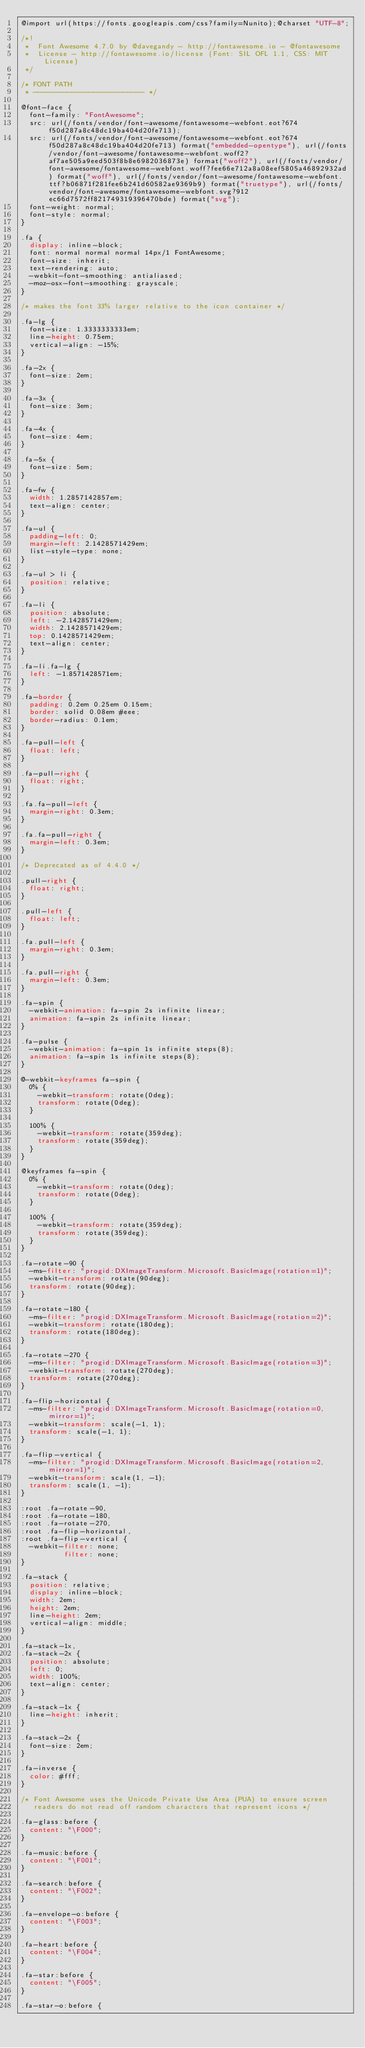Convert code to text. <code><loc_0><loc_0><loc_500><loc_500><_CSS_>@import url(https://fonts.googleapis.com/css?family=Nunito);@charset "UTF-8";

/*!
 *  Font Awesome 4.7.0 by @davegandy - http://fontawesome.io - @fontawesome
 *  License - http://fontawesome.io/license (Font: SIL OFL 1.1, CSS: MIT License)
 */

/* FONT PATH
 * -------------------------- */

@font-face {
  font-family: "FontAwesome";
  src: url(/fonts/vendor/font-awesome/fontawesome-webfont.eot?674f50d287a8c48dc19ba404d20fe713);
  src: url(/fonts/vendor/font-awesome/fontawesome-webfont.eot?674f50d287a8c48dc19ba404d20fe713) format("embedded-opentype"), url(/fonts/vendor/font-awesome/fontawesome-webfont.woff2?af7ae505a9eed503f8b8e6982036873e) format("woff2"), url(/fonts/vendor/font-awesome/fontawesome-webfont.woff?fee66e712a8a08eef5805a46892932ad) format("woff"), url(/fonts/vendor/font-awesome/fontawesome-webfont.ttf?b06871f281fee6b241d60582ae9369b9) format("truetype"), url(/fonts/vendor/font-awesome/fontawesome-webfont.svg?912ec66d7572ff821749319396470bde) format("svg");
  font-weight: normal;
  font-style: normal;
}

.fa {
  display: inline-block;
  font: normal normal normal 14px/1 FontAwesome;
  font-size: inherit;
  text-rendering: auto;
  -webkit-font-smoothing: antialiased;
  -moz-osx-font-smoothing: grayscale;
}

/* makes the font 33% larger relative to the icon container */

.fa-lg {
  font-size: 1.3333333333em;
  line-height: 0.75em;
  vertical-align: -15%;
}

.fa-2x {
  font-size: 2em;
}

.fa-3x {
  font-size: 3em;
}

.fa-4x {
  font-size: 4em;
}

.fa-5x {
  font-size: 5em;
}

.fa-fw {
  width: 1.2857142857em;
  text-align: center;
}

.fa-ul {
  padding-left: 0;
  margin-left: 2.1428571429em;
  list-style-type: none;
}

.fa-ul > li {
  position: relative;
}

.fa-li {
  position: absolute;
  left: -2.1428571429em;
  width: 2.1428571429em;
  top: 0.1428571429em;
  text-align: center;
}

.fa-li.fa-lg {
  left: -1.8571428571em;
}

.fa-border {
  padding: 0.2em 0.25em 0.15em;
  border: solid 0.08em #eee;
  border-radius: 0.1em;
}

.fa-pull-left {
  float: left;
}

.fa-pull-right {
  float: right;
}

.fa.fa-pull-left {
  margin-right: 0.3em;
}

.fa.fa-pull-right {
  margin-left: 0.3em;
}

/* Deprecated as of 4.4.0 */

.pull-right {
  float: right;
}

.pull-left {
  float: left;
}

.fa.pull-left {
  margin-right: 0.3em;
}

.fa.pull-right {
  margin-left: 0.3em;
}

.fa-spin {
  -webkit-animation: fa-spin 2s infinite linear;
  animation: fa-spin 2s infinite linear;
}

.fa-pulse {
  -webkit-animation: fa-spin 1s infinite steps(8);
  animation: fa-spin 1s infinite steps(8);
}

@-webkit-keyframes fa-spin {
  0% {
    -webkit-transform: rotate(0deg);
    transform: rotate(0deg);
  }

  100% {
    -webkit-transform: rotate(359deg);
    transform: rotate(359deg);
  }
}

@keyframes fa-spin {
  0% {
    -webkit-transform: rotate(0deg);
    transform: rotate(0deg);
  }

  100% {
    -webkit-transform: rotate(359deg);
    transform: rotate(359deg);
  }
}

.fa-rotate-90 {
  -ms-filter: "progid:DXImageTransform.Microsoft.BasicImage(rotation=1)";
  -webkit-transform: rotate(90deg);
  transform: rotate(90deg);
}

.fa-rotate-180 {
  -ms-filter: "progid:DXImageTransform.Microsoft.BasicImage(rotation=2)";
  -webkit-transform: rotate(180deg);
  transform: rotate(180deg);
}

.fa-rotate-270 {
  -ms-filter: "progid:DXImageTransform.Microsoft.BasicImage(rotation=3)";
  -webkit-transform: rotate(270deg);
  transform: rotate(270deg);
}

.fa-flip-horizontal {
  -ms-filter: "progid:DXImageTransform.Microsoft.BasicImage(rotation=0, mirror=1)";
  -webkit-transform: scale(-1, 1);
  transform: scale(-1, 1);
}

.fa-flip-vertical {
  -ms-filter: "progid:DXImageTransform.Microsoft.BasicImage(rotation=2, mirror=1)";
  -webkit-transform: scale(1, -1);
  transform: scale(1, -1);
}

:root .fa-rotate-90,
:root .fa-rotate-180,
:root .fa-rotate-270,
:root .fa-flip-horizontal,
:root .fa-flip-vertical {
  -webkit-filter: none;
          filter: none;
}

.fa-stack {
  position: relative;
  display: inline-block;
  width: 2em;
  height: 2em;
  line-height: 2em;
  vertical-align: middle;
}

.fa-stack-1x,
.fa-stack-2x {
  position: absolute;
  left: 0;
  width: 100%;
  text-align: center;
}

.fa-stack-1x {
  line-height: inherit;
}

.fa-stack-2x {
  font-size: 2em;
}

.fa-inverse {
  color: #fff;
}

/* Font Awesome uses the Unicode Private Use Area (PUA) to ensure screen
   readers do not read off random characters that represent icons */

.fa-glass:before {
  content: "\F000";
}

.fa-music:before {
  content: "\F001";
}

.fa-search:before {
  content: "\F002";
}

.fa-envelope-o:before {
  content: "\F003";
}

.fa-heart:before {
  content: "\F004";
}

.fa-star:before {
  content: "\F005";
}

.fa-star-o:before {</code> 